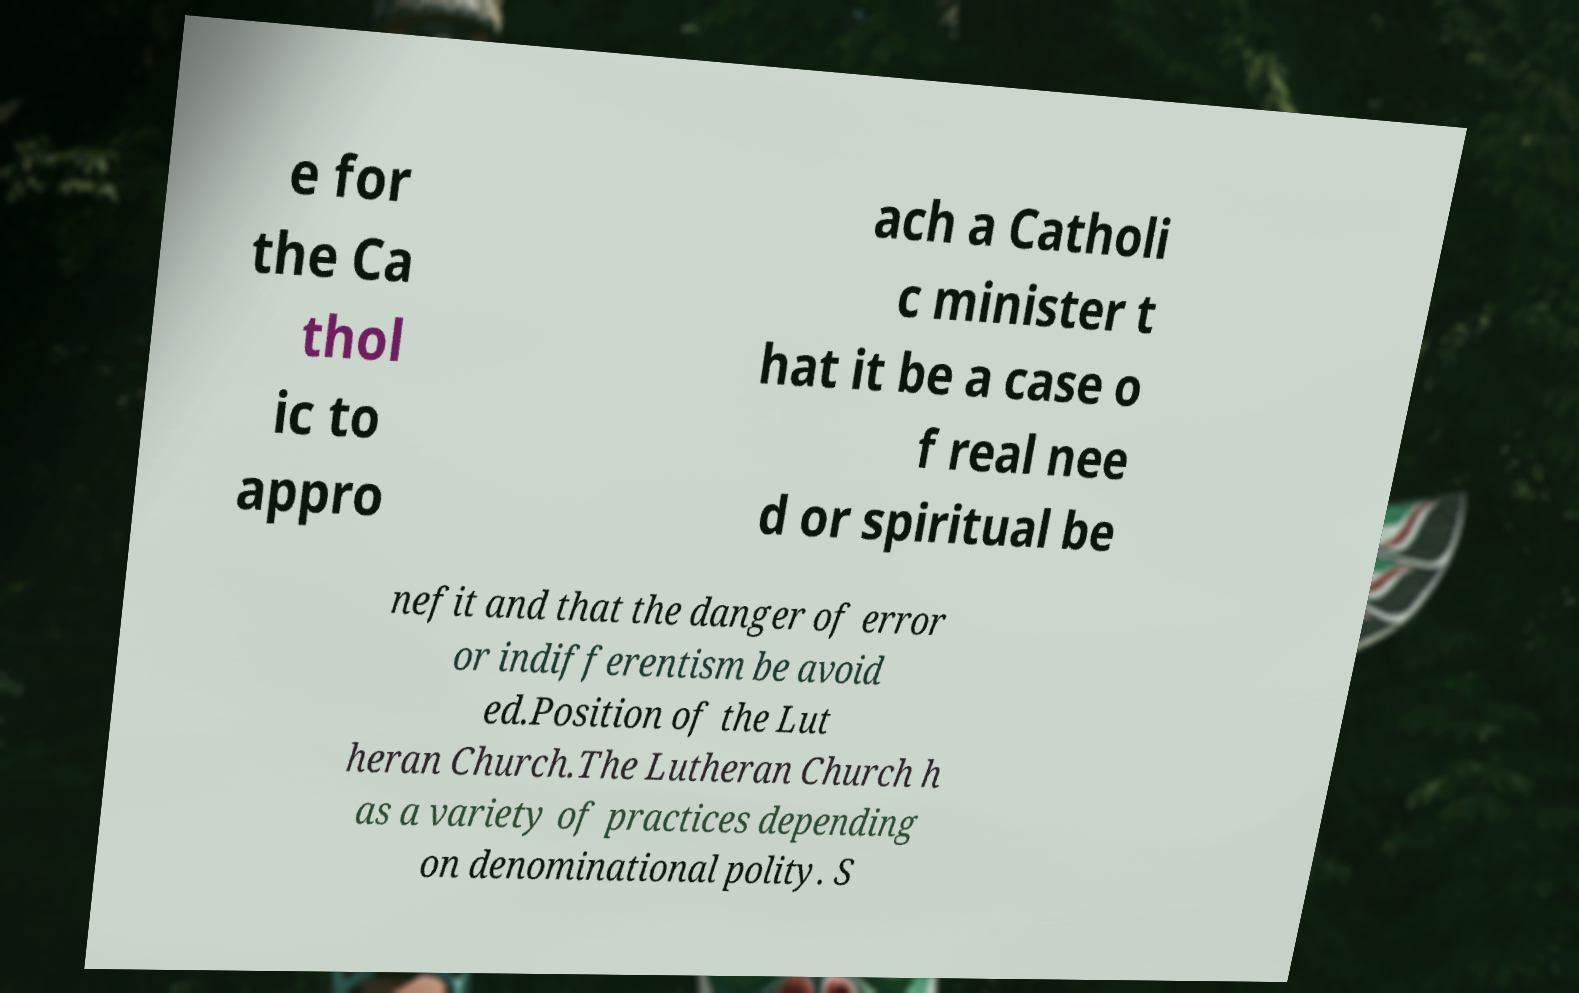Please read and relay the text visible in this image. What does it say? e for the Ca thol ic to appro ach a Catholi c minister t hat it be a case o f real nee d or spiritual be nefit and that the danger of error or indifferentism be avoid ed.Position of the Lut heran Church.The Lutheran Church h as a variety of practices depending on denominational polity. S 